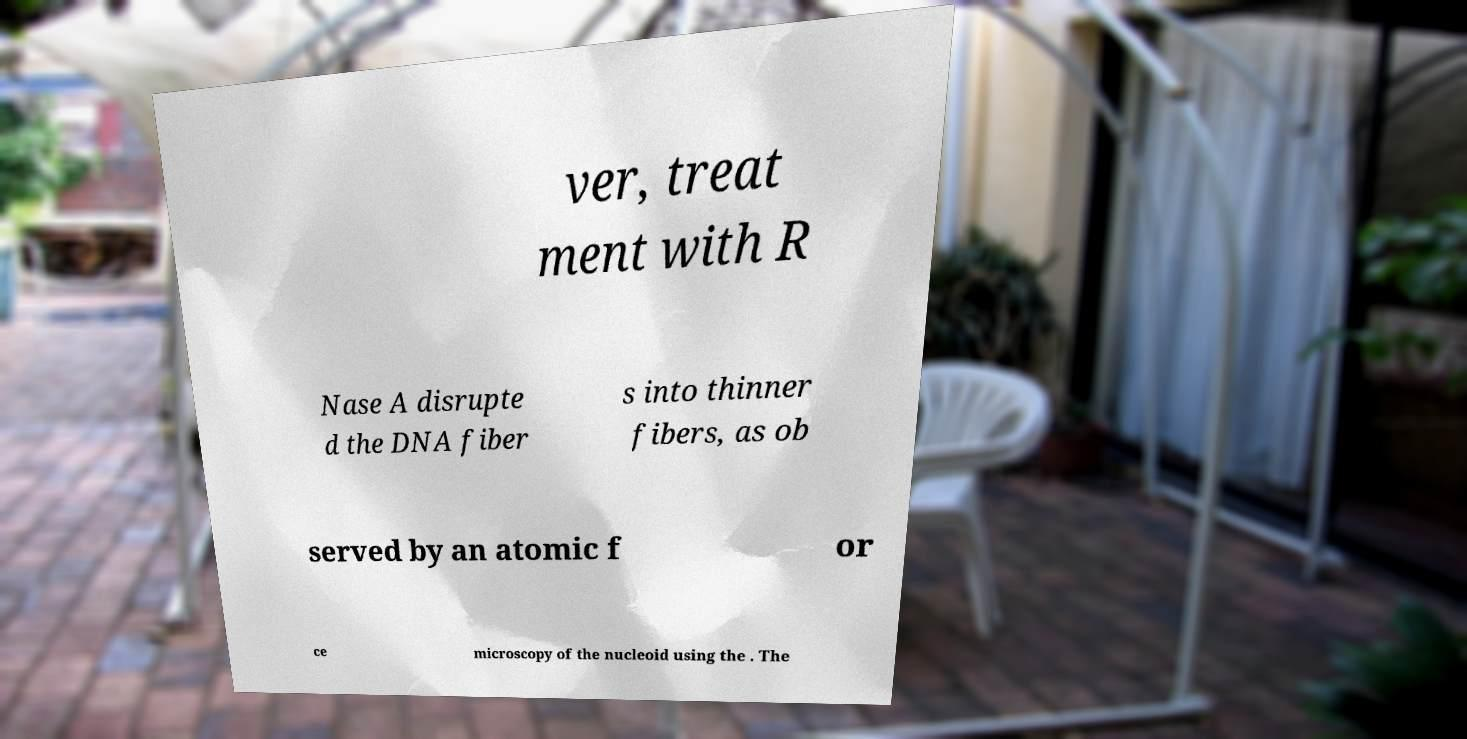Please read and relay the text visible in this image. What does it say? ver, treat ment with R Nase A disrupte d the DNA fiber s into thinner fibers, as ob served by an atomic f or ce microscopy of the nucleoid using the . The 